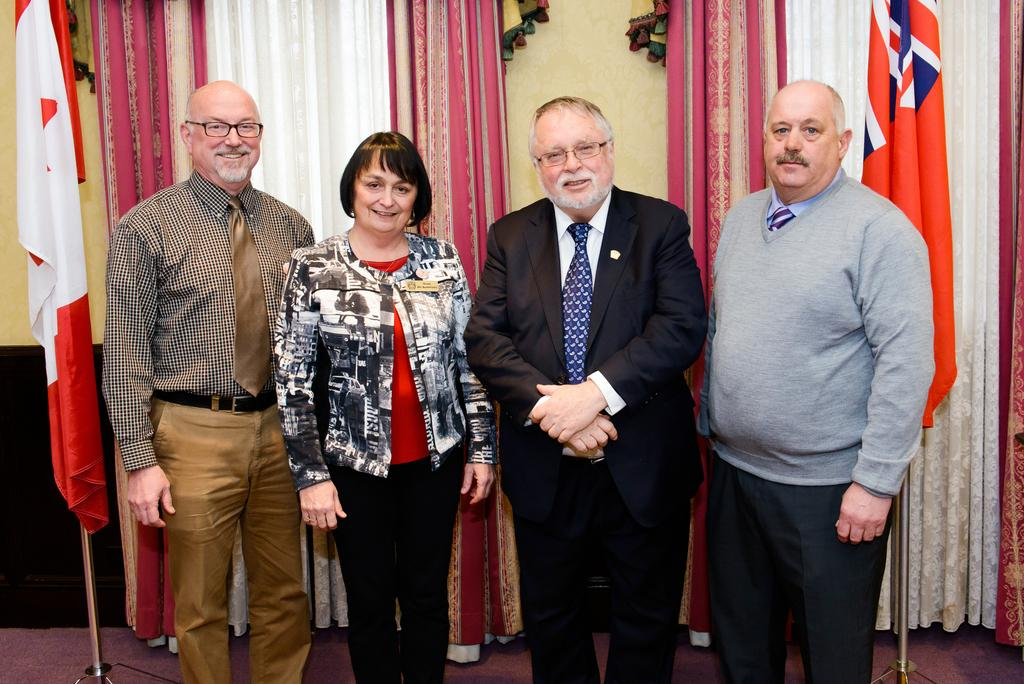How many people are in the image? There is a group of people standing in the image. Where are the people standing? The people are standing on the floor. What can be seen in the background of the image? There are flags on poles and curtains in the background of the image. What type of structure is visible in the background? There is a wall in the background of the image. What type of mitten is being used to control the waves in the image? There is no mitten or waves present in the image. Is the minister visible in the image? There is no minister present in the image. 